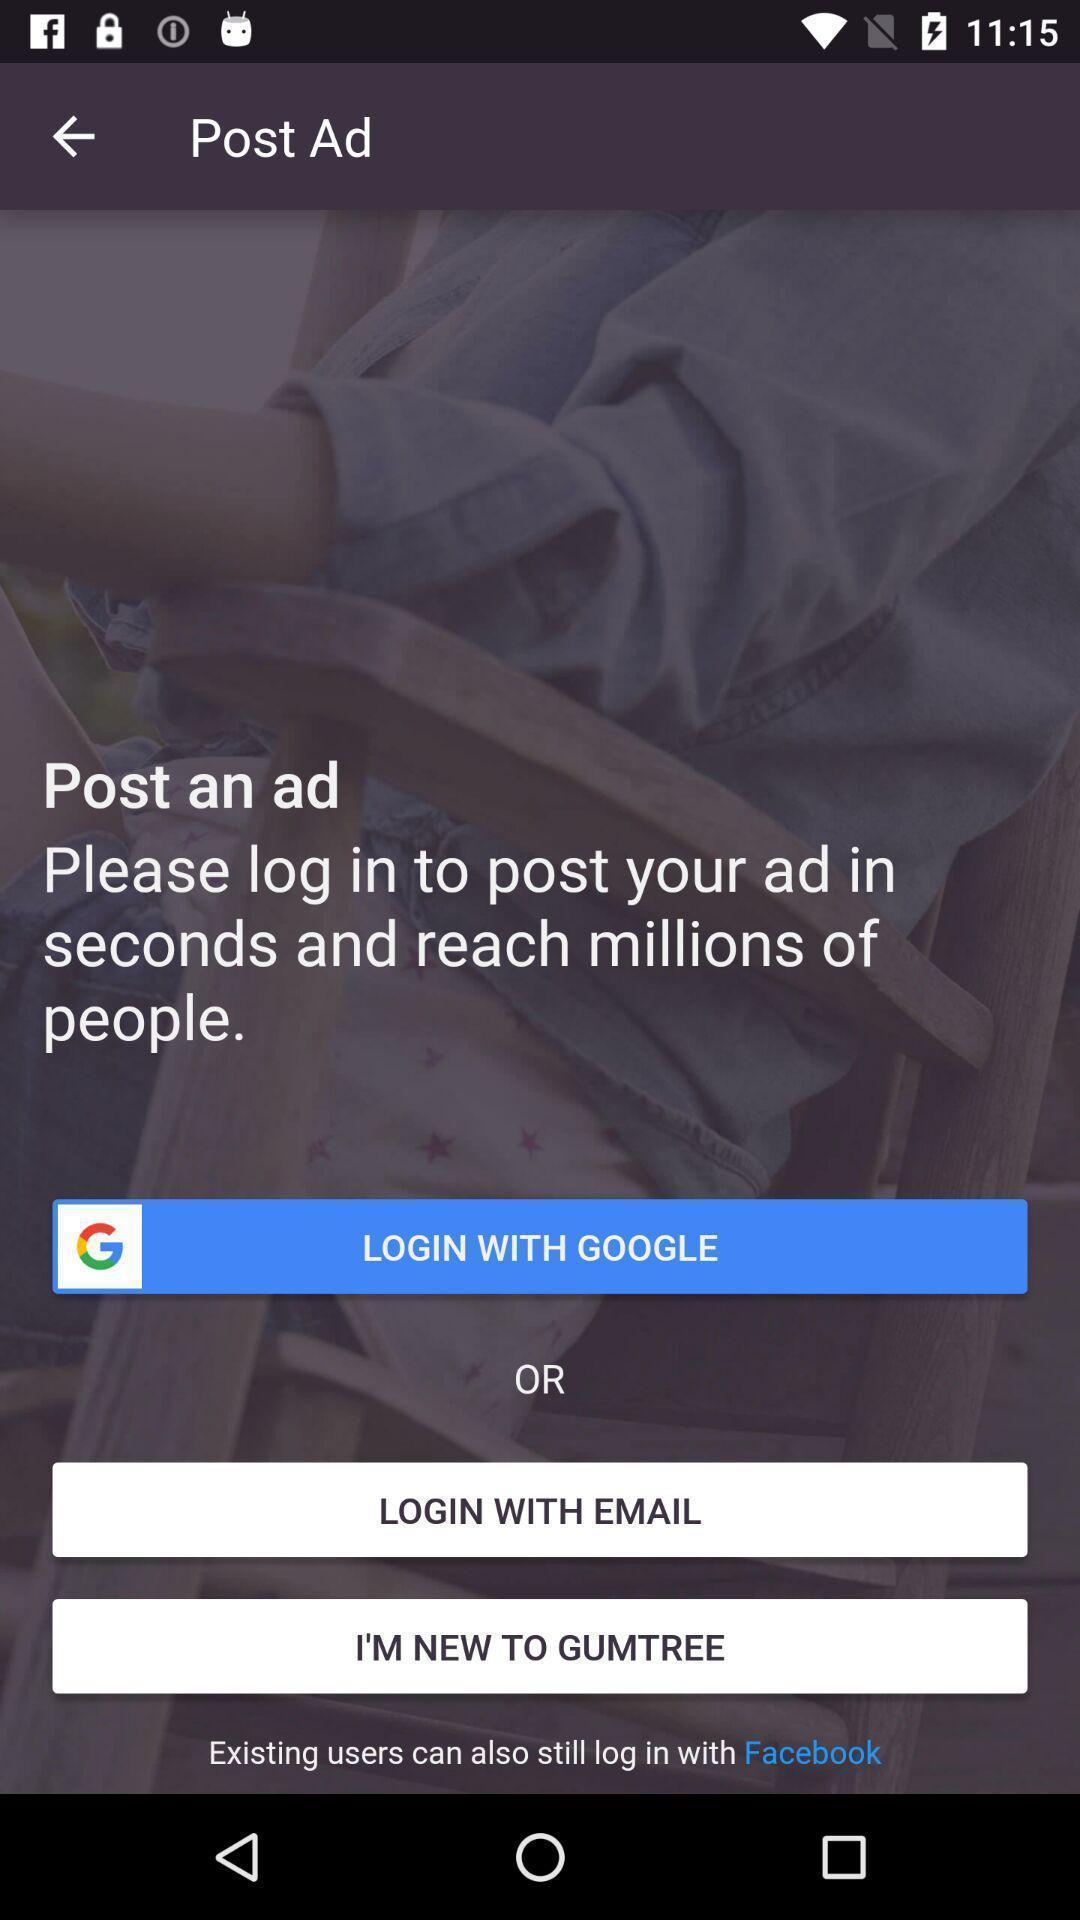Explain the elements present in this screenshot. Login page. 